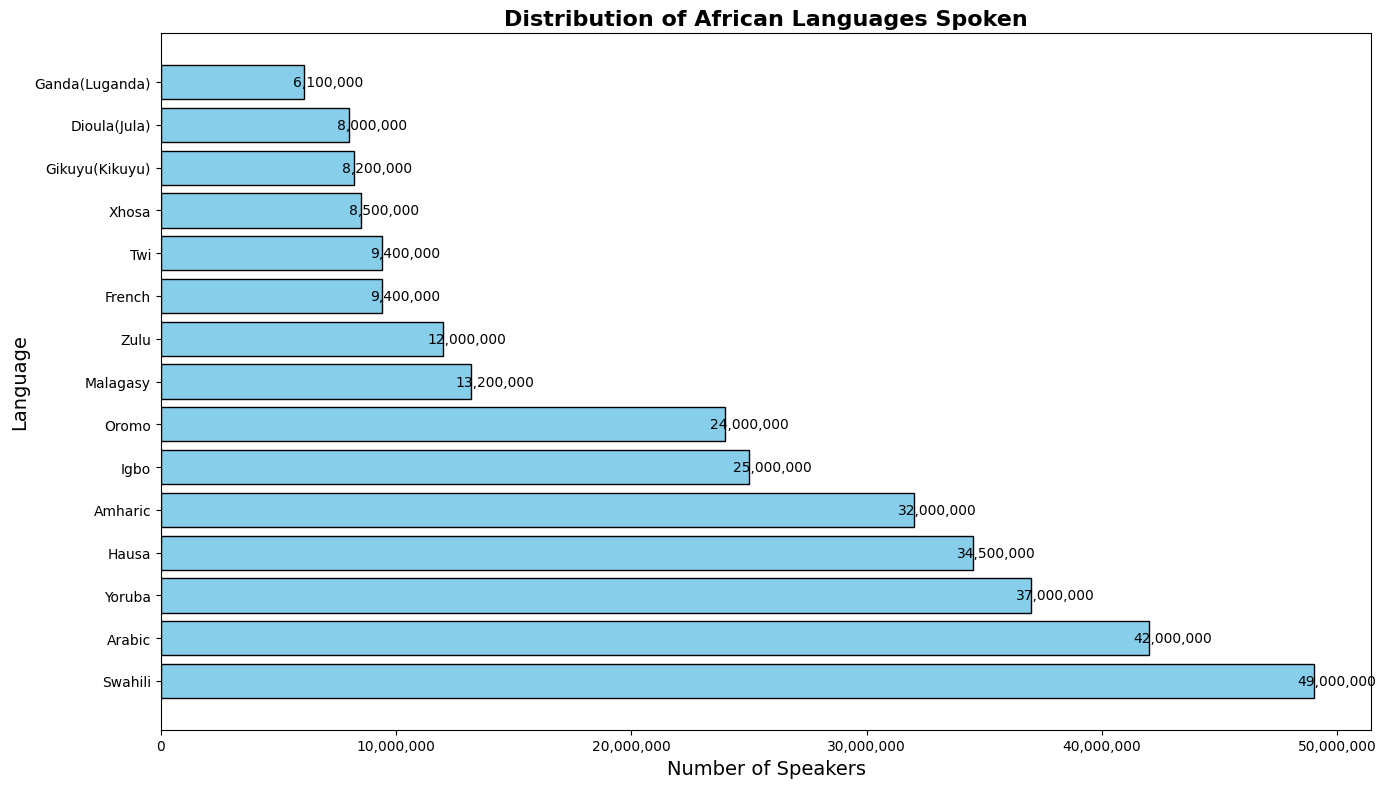Which language has the highest number of speakers? To determine which language has the most speakers, look at the horizontal bar with the longest length—the text label within or at the end will indicate the language.
Answer: Yoruba Which language has more speakers: Hausa or Zulu? Compare the lengths of the bars for Hausa and Zulu. The bar for Hausa (analyzed by adding the numbers for Nigeria and Niger) should be longer than the bar for Zulu.
Answer: Hausa How many languages have more than 20 million speakers? Scan the lengths of the bars and count the number of bars representing languages with more than 20 million speakers. There should be 7 such languages: Yoruba, Amharic, Arabic, Swahili, Hausa, Igbo, and Malagasy.
Answer: 7 What is the total number of Yoruba speakers? Check the bar length and corresponding label for Yoruba. The text label at the end indicates the number of speakers.
Answer: 37,000,000 Which country has the highest number of speakers for a single language? To figure this out, look at the country labels and compare the individual bars. Yoruba in Nigeria has the highest number.
Answer: Nigeria By how many speakers does Amharic exceed Zulu? Find the difference in bar lengths (number of speakers) between Amharic and Zulu. Amharic has 32,000,000 speakers and Zulu has 12,000,000. The difference is 32,000,000 - 12,000,000.
Answer: 20,000,000 How many speakers speak languages originating from South Africa? Add the numbers indicated by the bars for Zulu and Xhosa, which are both spoken in South Africa.
Answer: 20,500,000 Which language spoken in East Africa has the most speakers? Identify the languages spoken in East Africa (e.g., Swahili, Gikuyu) and compare their corresponding bar lengths. Swahili has the most speakers.
Answer: Swahili How does the number of Swahili speakers in Kenya compare to Tanzania? Compare the lengths of bars for Swahili speakers in both Kenya and Tanzania. Swahili speakers in Tanzania outnumber those in Kenya (20,000,000 vs. 14,000,000).
Answer: Tanzania has more Which two countries have more than 12 million speakers of Arabic collectively? Identify the bars for Arabic in different countries and compare them. Collectively, Chad and Sudan have more than 12 million speakers.
Answer: Chad and Sudan 